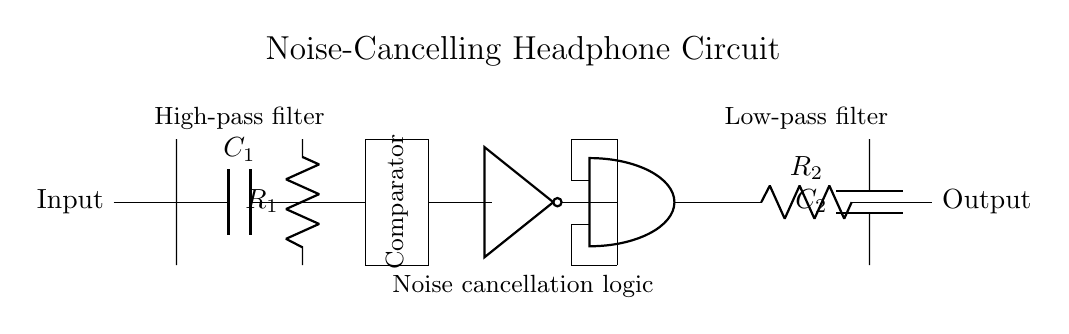What is the input of the circuit? The input is the starting point of the circuit, which is labeled as "Input" on the left side.
Answer: Input What type of filter is represented at the beginning? The component labeled as C1 is part of a high-pass filter, allowing high frequencies to pass through while blocking lower frequencies.
Answer: High-pass filter What function does the comparator serve in this circuit? The comparator checks the input signal against a reference point and changes its output accordingly, which is crucial for noise cancellation to determine whether to block or let sounds through.
Answer: Comparator What outputs does the AND gate have? The AND gate produces a logic high output only when both of its inputs are high, indicating that noise cancellation needs to occur.
Answer: Logic high What is the purpose of the low-pass filter? The low-pass filter, represented by R2 and C2, allows low frequencies to pass while attenuating high frequencies, which is important for filtering out unwanted noise after processing the signal.
Answer: Low-pass filter How is noise cancellation achieved in this circuit? Noise cancellation is achieved by using the NOT gate and the AND gate in conjunction with the comparator, enabling the circuit to selectively filter out triggering sounds based on input processing.
Answer: Logic gates What components are connected in series to make noise cancellation effective? The series components include the high-pass filter, the comparator, the NOT gate, and the AND gate, which together process the input signal to effectively cancel noise.
Answer: High-pass filter, comparator, NOT gate, AND gate 